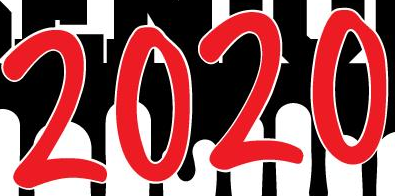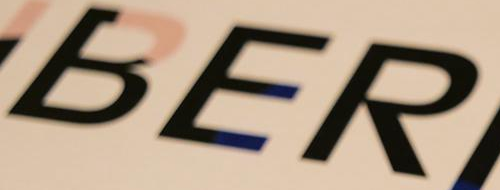What text is displayed in these images sequentially, separated by a semicolon? 2020; BER 